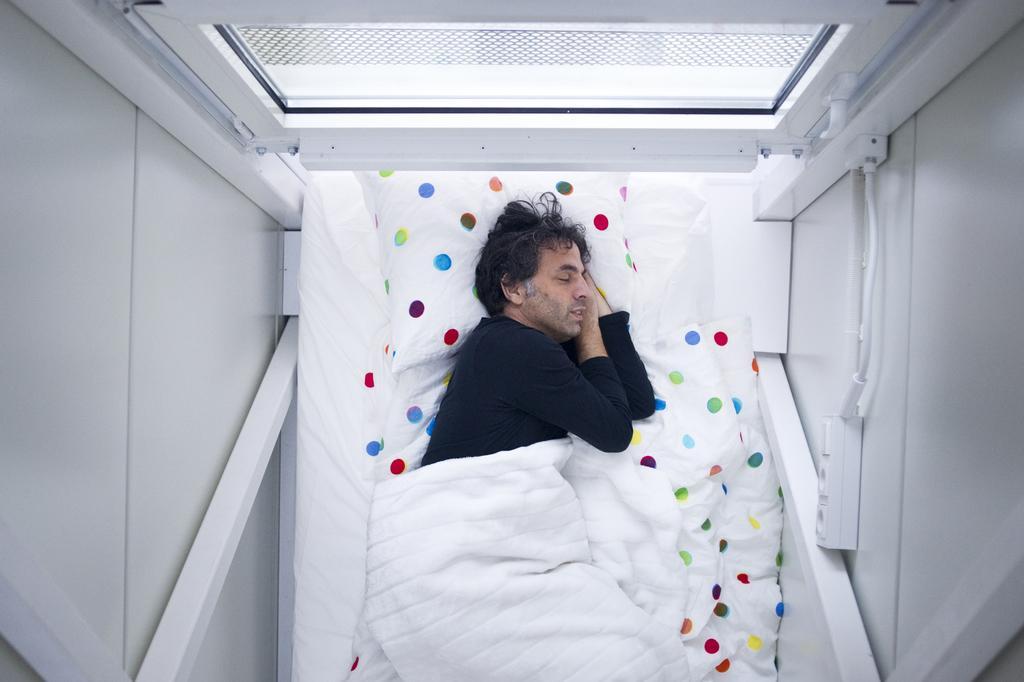Please provide a concise description of this image. In this picture we can see a man sleeping on a bed with a bed sheet on his, pillow and in the background we can see a window. 